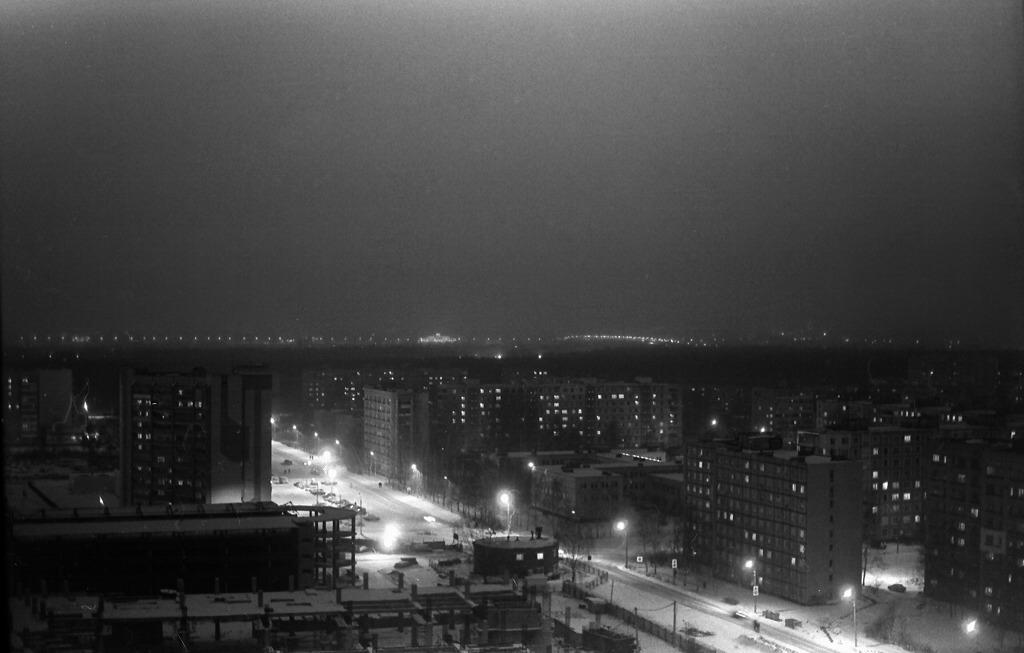Please provide a concise description of this image. In this image we can see few buildings, streetlights and the sky in the background. 